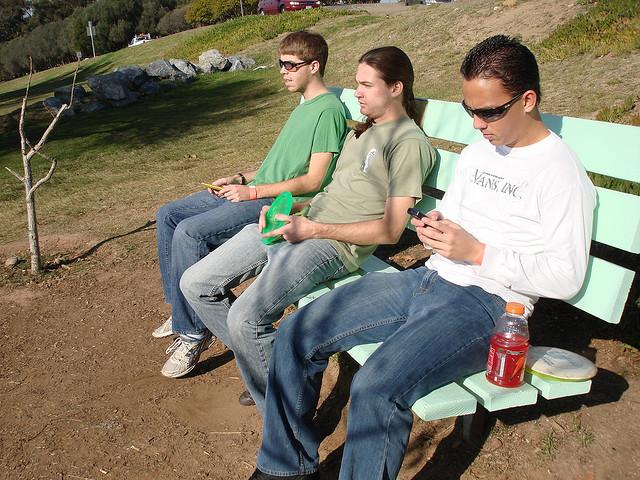Do the young men have on the same color shirts?
Concise answer only. No. Are they having a picnic?
Answer briefly. No. What color is the Gatorade?
Write a very short answer. Red. What is the man in the middle holding?
Give a very brief answer. Frisbee. 